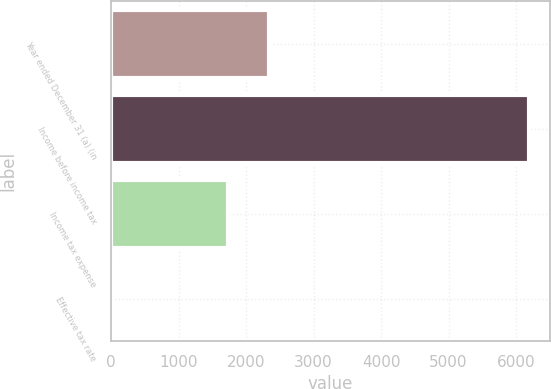Convert chart to OTSL. <chart><loc_0><loc_0><loc_500><loc_500><bar_chart><fcel>Year ended December 31 (a) (in<fcel>Income before income tax<fcel>Income tax expense<fcel>Effective tax rate<nl><fcel>2344.61<fcel>6194<fcel>1728<fcel>27.9<nl></chart> 